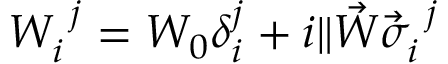<formula> <loc_0><loc_0><loc_500><loc_500>W _ { i } ^ { j } = W _ { 0 } \delta _ { i } ^ { j } + i \| \vec { W } \vec { \sigma } _ { i } ^ { j }</formula> 